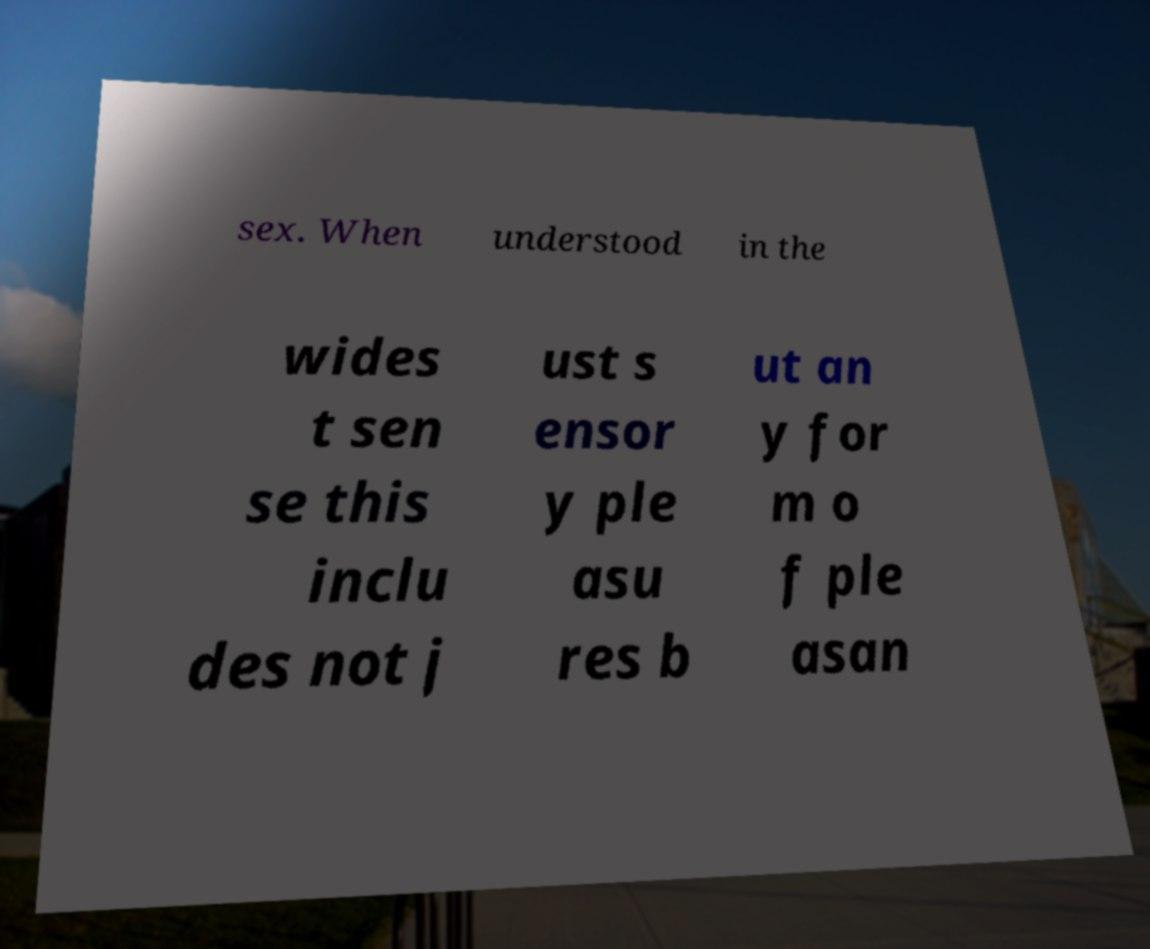I need the written content from this picture converted into text. Can you do that? sex. When understood in the wides t sen se this inclu des not j ust s ensor y ple asu res b ut an y for m o f ple asan 